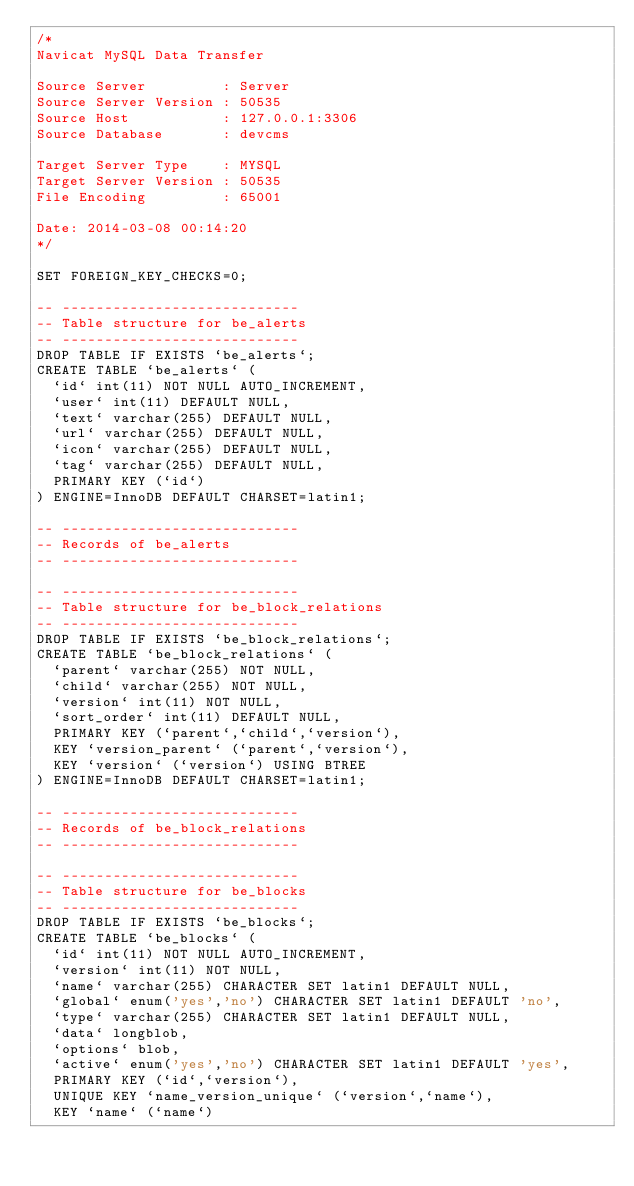Convert code to text. <code><loc_0><loc_0><loc_500><loc_500><_SQL_>/*
Navicat MySQL Data Transfer

Source Server         : Server
Source Server Version : 50535
Source Host           : 127.0.0.1:3306
Source Database       : devcms

Target Server Type    : MYSQL
Target Server Version : 50535
File Encoding         : 65001

Date: 2014-03-08 00:14:20
*/

SET FOREIGN_KEY_CHECKS=0;

-- ----------------------------
-- Table structure for be_alerts
-- ----------------------------
DROP TABLE IF EXISTS `be_alerts`;
CREATE TABLE `be_alerts` (
  `id` int(11) NOT NULL AUTO_INCREMENT,
  `user` int(11) DEFAULT NULL,
  `text` varchar(255) DEFAULT NULL,
  `url` varchar(255) DEFAULT NULL,
  `icon` varchar(255) DEFAULT NULL,
  `tag` varchar(255) DEFAULT NULL,
  PRIMARY KEY (`id`)
) ENGINE=InnoDB DEFAULT CHARSET=latin1;

-- ----------------------------
-- Records of be_alerts
-- ----------------------------

-- ----------------------------
-- Table structure for be_block_relations
-- ----------------------------
DROP TABLE IF EXISTS `be_block_relations`;
CREATE TABLE `be_block_relations` (
  `parent` varchar(255) NOT NULL,
  `child` varchar(255) NOT NULL,
  `version` int(11) NOT NULL,
  `sort_order` int(11) DEFAULT NULL,
  PRIMARY KEY (`parent`,`child`,`version`),
  KEY `version_parent` (`parent`,`version`),
  KEY `version` (`version`) USING BTREE
) ENGINE=InnoDB DEFAULT CHARSET=latin1;

-- ----------------------------
-- Records of be_block_relations
-- ----------------------------

-- ----------------------------
-- Table structure for be_blocks
-- ----------------------------
DROP TABLE IF EXISTS `be_blocks`;
CREATE TABLE `be_blocks` (
  `id` int(11) NOT NULL AUTO_INCREMENT,
  `version` int(11) NOT NULL,
  `name` varchar(255) CHARACTER SET latin1 DEFAULT NULL,
  `global` enum('yes','no') CHARACTER SET latin1 DEFAULT 'no',
  `type` varchar(255) CHARACTER SET latin1 DEFAULT NULL,
  `data` longblob,
  `options` blob,
  `active` enum('yes','no') CHARACTER SET latin1 DEFAULT 'yes',
  PRIMARY KEY (`id`,`version`),
  UNIQUE KEY `name_version_unique` (`version`,`name`),
  KEY `name` (`name`)</code> 